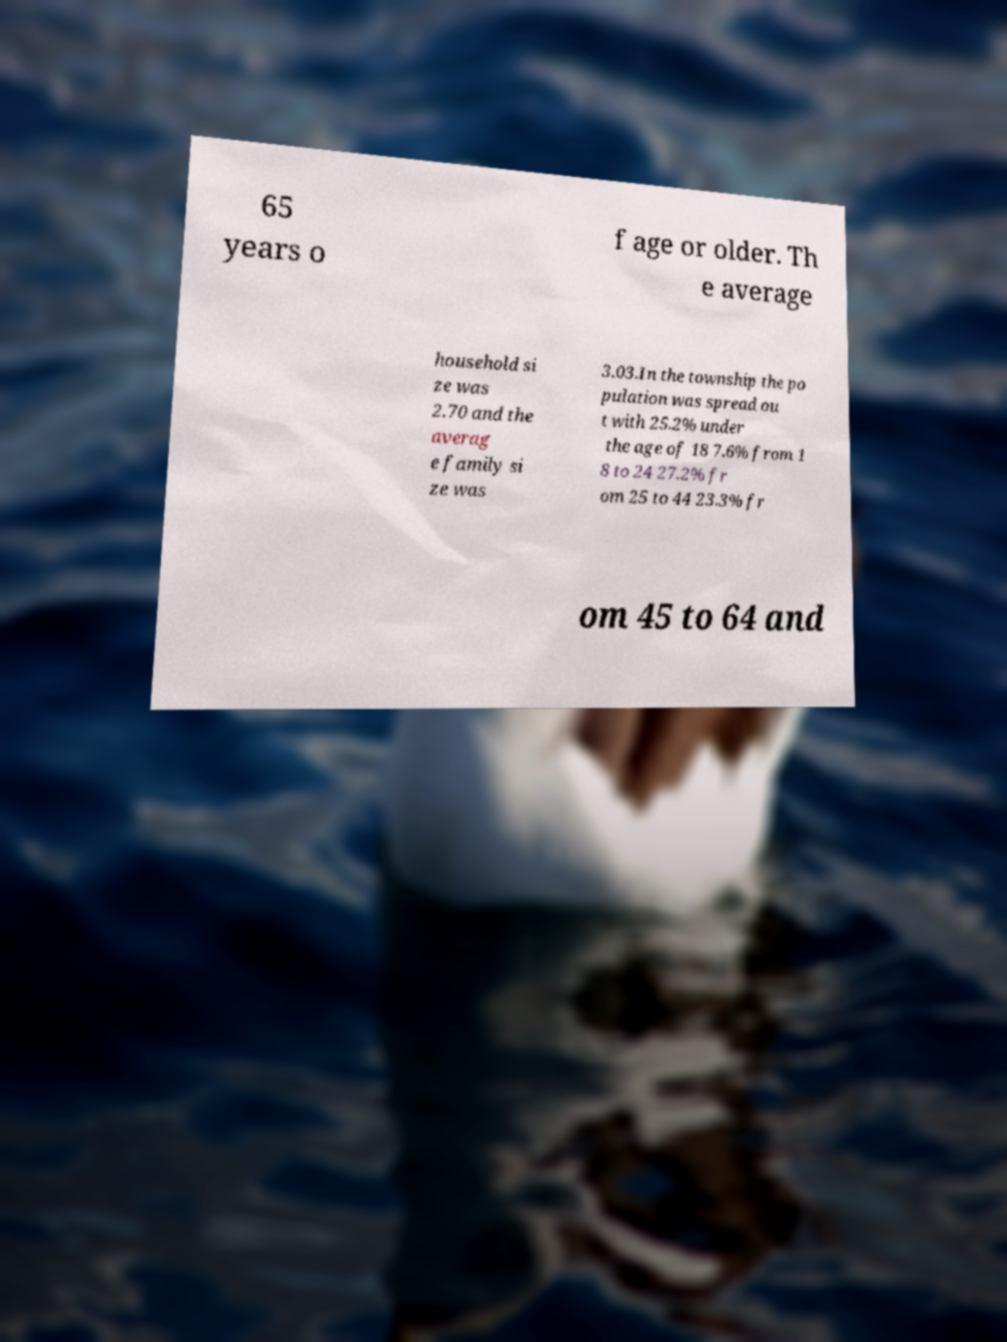I need the written content from this picture converted into text. Can you do that? 65 years o f age or older. Th e average household si ze was 2.70 and the averag e family si ze was 3.03.In the township the po pulation was spread ou t with 25.2% under the age of 18 7.6% from 1 8 to 24 27.2% fr om 25 to 44 23.3% fr om 45 to 64 and 